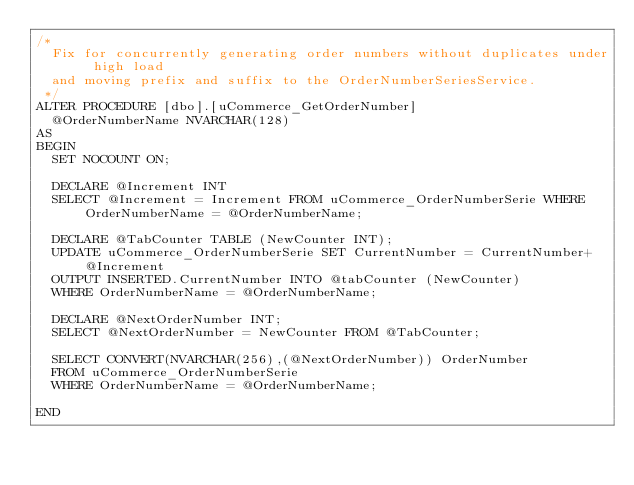<code> <loc_0><loc_0><loc_500><loc_500><_SQL_>/*
	Fix for concurrently generating order numbers without duplicates under high load
	and moving prefix and suffix to the OrderNumberSeriesService.
 */
ALTER PROCEDURE [dbo].[uCommerce_GetOrderNumber]
	@OrderNumberName NVARCHAR(128)
AS
BEGIN	
	SET NOCOUNT ON;

	DECLARE @Increment INT
	SELECT @Increment = Increment FROM uCommerce_OrderNumberSerie WHERE OrderNumberName = @OrderNumberName;

	DECLARE @TabCounter TABLE (NewCounter INT);
	UPDATE uCommerce_OrderNumberSerie SET CurrentNumber = CurrentNumber+@Increment
	OUTPUT INSERTED.CurrentNumber INTO @tabCounter (NewCounter)
	WHERE OrderNumberName = @OrderNumberName;

	DECLARE @NextOrderNumber INT;
	SELECT @NextOrderNumber = NewCounter FROM @TabCounter;

	SELECT CONVERT(NVARCHAR(256),(@NextOrderNumber)) OrderNumber
	FROM uCommerce_OrderNumberSerie 
	WHERE OrderNumberName = @OrderNumberName;

END</code> 